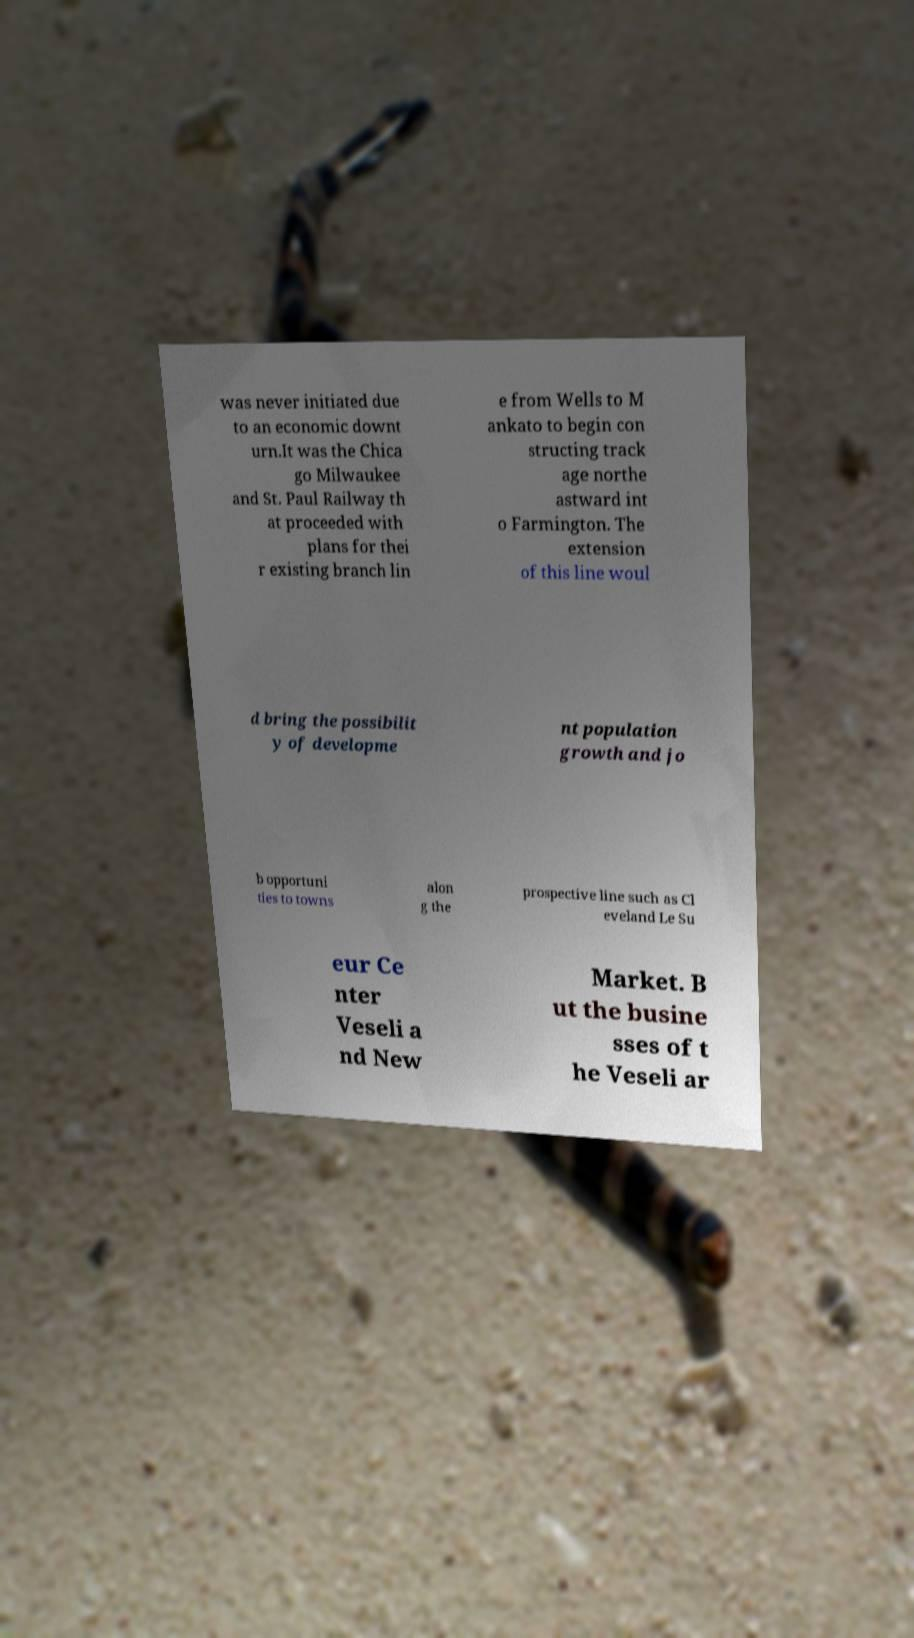Please read and relay the text visible in this image. What does it say? was never initiated due to an economic downt urn.It was the Chica go Milwaukee and St. Paul Railway th at proceeded with plans for thei r existing branch lin e from Wells to M ankato to begin con structing track age northe astward int o Farmington. The extension of this line woul d bring the possibilit y of developme nt population growth and jo b opportuni ties to towns alon g the prospective line such as Cl eveland Le Su eur Ce nter Veseli a nd New Market. B ut the busine sses of t he Veseli ar 